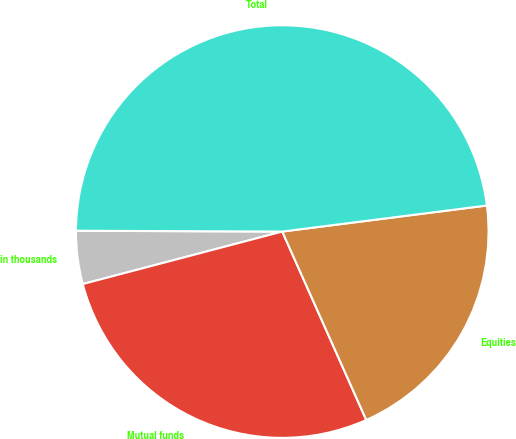Convert chart. <chart><loc_0><loc_0><loc_500><loc_500><pie_chart><fcel>in thousands<fcel>Mutual funds<fcel>Equities<fcel>Total<nl><fcel>4.16%<fcel>27.58%<fcel>20.34%<fcel>47.92%<nl></chart> 